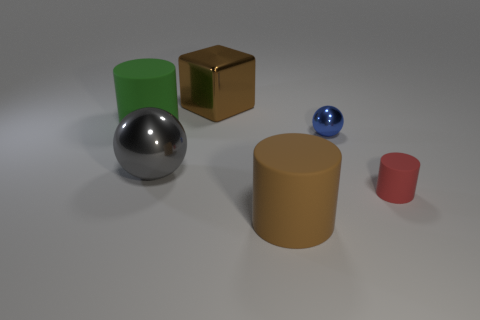What is the material of the thing behind the big green rubber object?
Keep it short and to the point. Metal. The large thing that is both left of the large brown rubber cylinder and right of the big gray shiny sphere has what shape?
Give a very brief answer. Cube. What is the small red thing made of?
Your answer should be compact. Rubber. What number of cylinders are big gray things or brown matte objects?
Provide a short and direct response. 1. Is the gray thing made of the same material as the red cylinder?
Your answer should be very brief. No. The red object that is the same shape as the large brown matte object is what size?
Your answer should be very brief. Small. There is a cylinder that is in front of the tiny blue metallic ball and on the left side of the small cylinder; what material is it?
Make the answer very short. Rubber. Are there the same number of tiny objects right of the tiny red thing and small matte objects?
Keep it short and to the point. No. How many things are big objects that are behind the tiny blue shiny ball or red metallic objects?
Your answer should be compact. 2. Is the color of the rubber thing behind the tiny blue shiny thing the same as the small metal sphere?
Keep it short and to the point. No. 